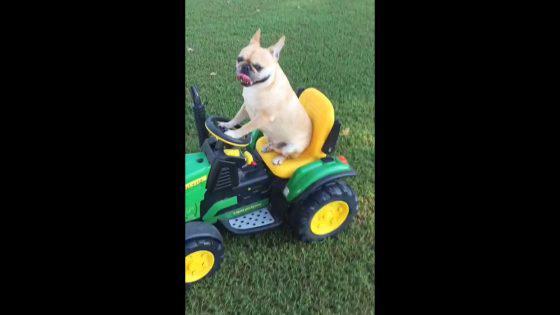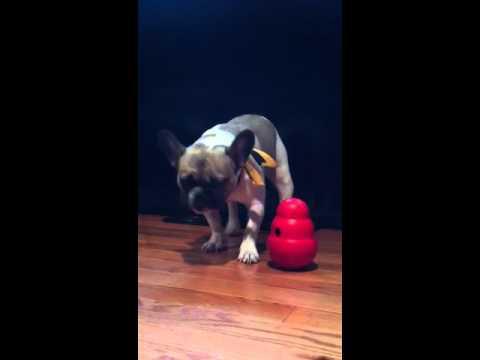The first image is the image on the left, the second image is the image on the right. Examine the images to the left and right. Is the description "Each dog is wearing some kind of costume." accurate? Answer yes or no. No. The first image is the image on the left, the second image is the image on the right. Analyze the images presented: Is the assertion "In one of the image the dog is looking to the right." valid? Answer yes or no. No. 